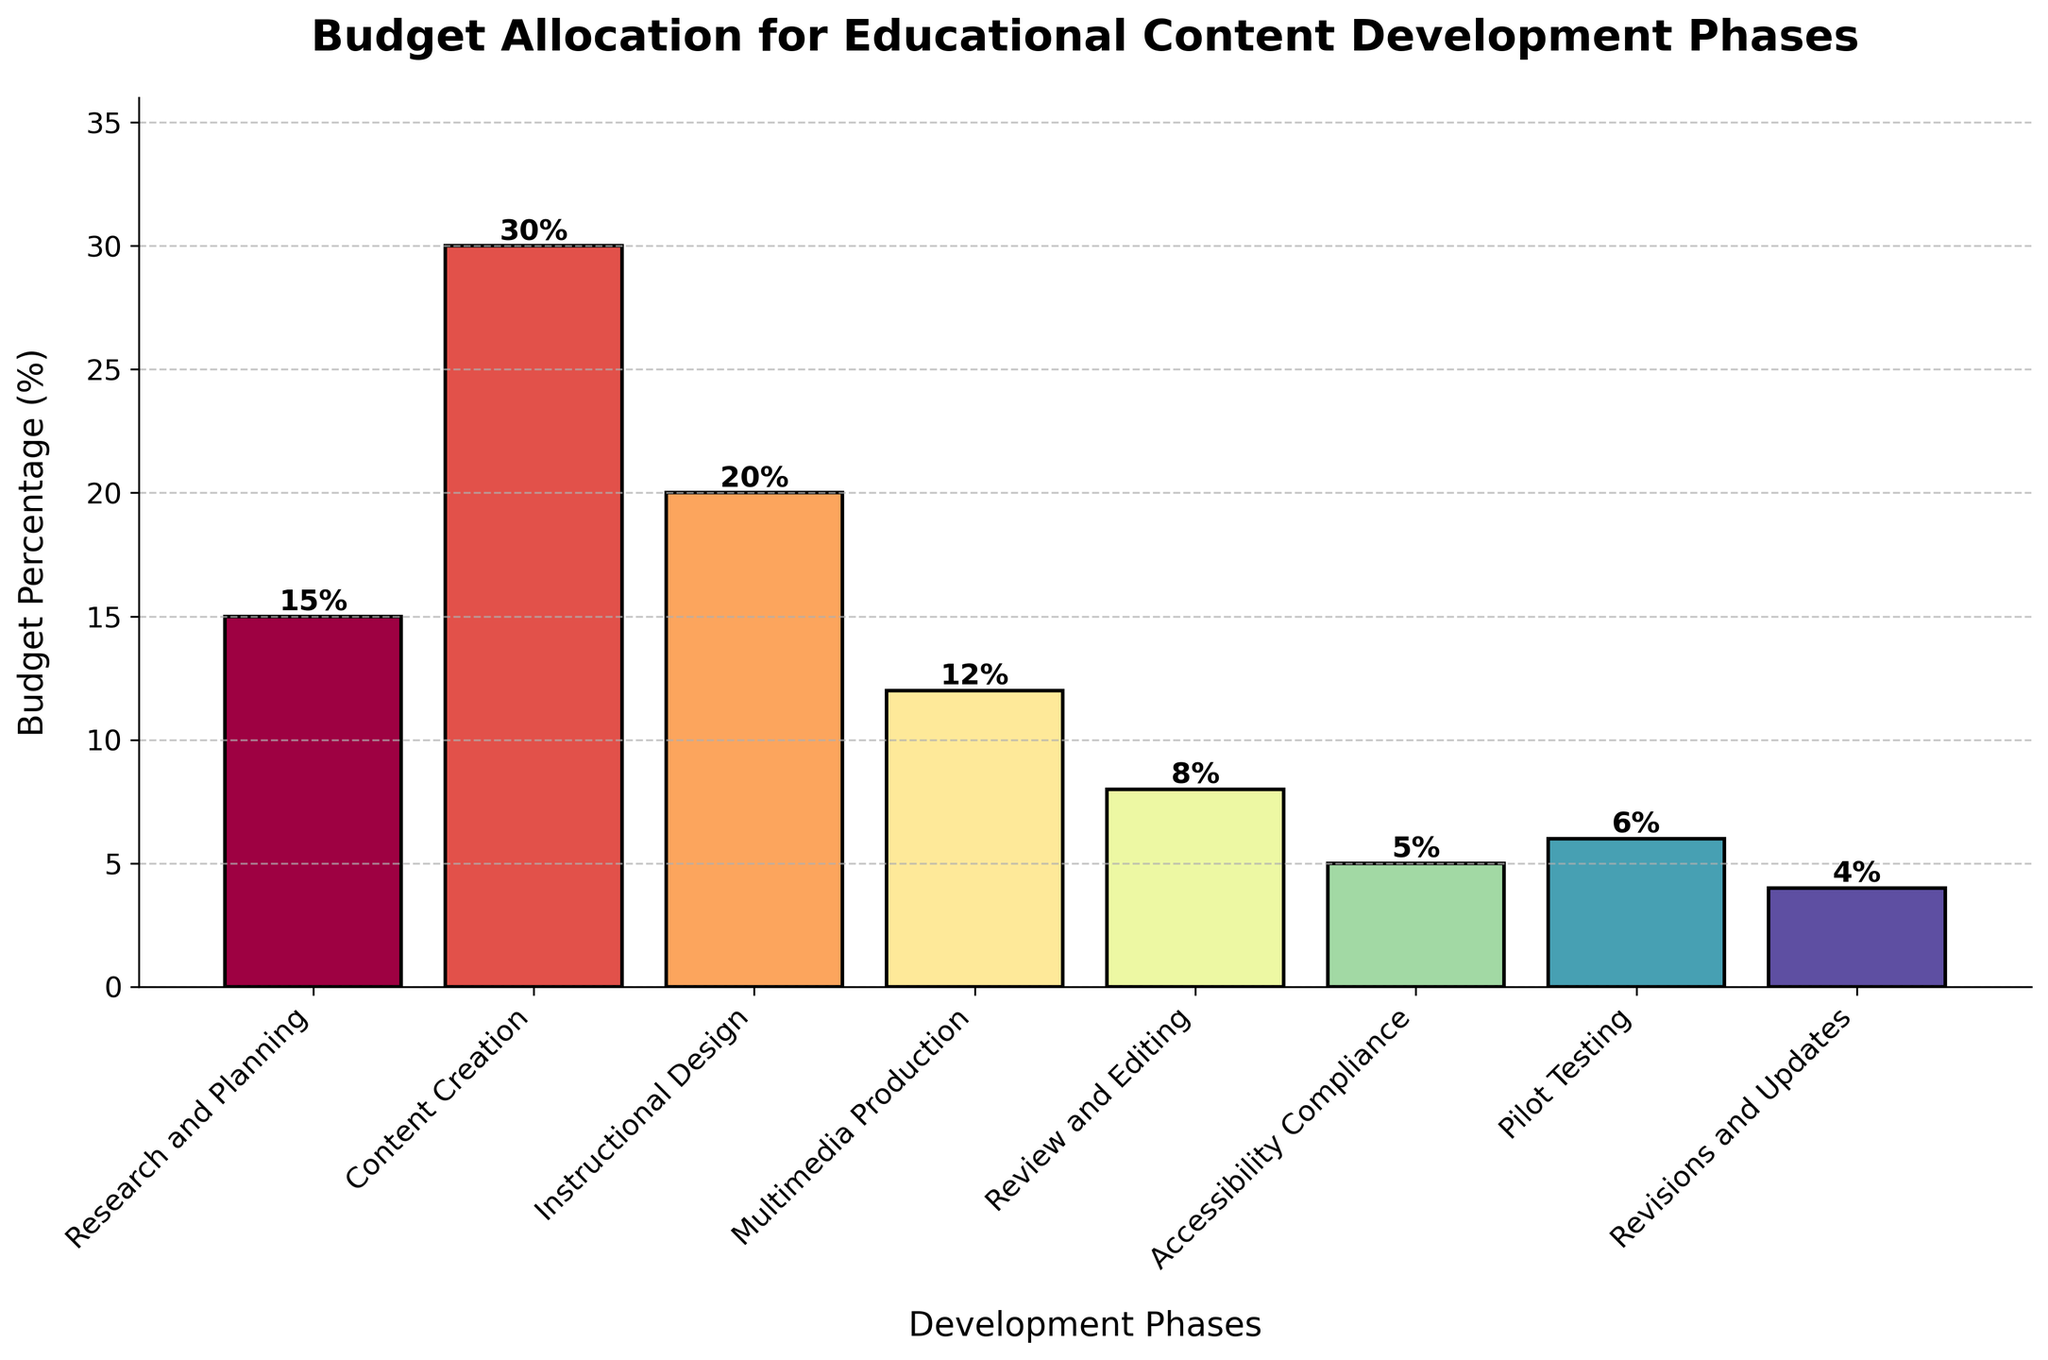What phase has the highest budget allocation? The tallest bar in the bar chart represents the phase with the highest budget allocation. The tallest bar is for "Content Creation", which has a budget percentage of 30%.
Answer: Content Creation What is the combined budget percentage for Research and Planning, and Review and Editing? Identify the bars for "Research and Planning" and "Review and Editing". The heights of these bars are 15% and 8%, respectively. Summing these values gives 15% + 8% = 23%.
Answer: 23% How much higher is the budget for Content Creation compared to Multimedia Production? Identify the bars for "Content Creation" and "Multimedia Production". Their heights are 30% and 12%, respectively. The difference is 30% - 12% = 18%.
Answer: 18% Which phase has a lower budget: Accessibility Compliance or Pilot Testing? Compare the heights of the bars for "Accessibility Compliance" and "Pilot Testing". "Accessibility Compliance" has 5% while "Pilot Testing" has 6%. Since 5% is less than 6%, "Accessibility Compliance" has a lower budget.
Answer: Accessibility Compliance Is the budget for Instructional Design higher than 15%? Identify the bar for "Instructional Design" and check if its height exceeds 15%. The height of the "Instructional Design" bar is 20%, which is higher than 15%.
Answer: Yes What is the total budget percentage for all phases combined? Sum the heights of all bars in the figure representing each phase. The sum is 15% + 30% + 20% + 12% + 8% + 5% + 6% + 4% = 100%.
Answer: 100% Which phases have a budget percentage less than 10%? Identify the bars with heights less than 10%. These bars correspond to "Review and Editing" (8%), "Accessibility Compliance" (5%), "Pilot Testing" (6%), and "Revisions and Updates" (4%).
Answer: Review and Editing, Accessibility Compliance, Pilot Testing, Revisions and Updates Between Content Creation and Instructional Design, which phase has a shorter bar and by how much? Compare the heights of the bars for "Content Creation" (30%) and "Instructional Design" (20%). The difference is 30% - 20% = 10%.
Answer: Instructional Design, 10% What color appears to represent the bar for Pilot Testing? Visually examine the color shade representing "Pilot Testing". The section for "Pilot Testing" appears with a distinct color compared to others; it uses a lighter shade similar to green or yellow.
Answer: Light greenish-yellow How does the height of the bar for Research and Planning compare to the bar for Revisions and Updates? Observe the heights of the bars for "Research and Planning" (15%) and "Revisions and Updates" (4%). Since 15% is greater than 4%, the bar for "Research and Planning" is taller.
Answer: Research and Planning is taller 